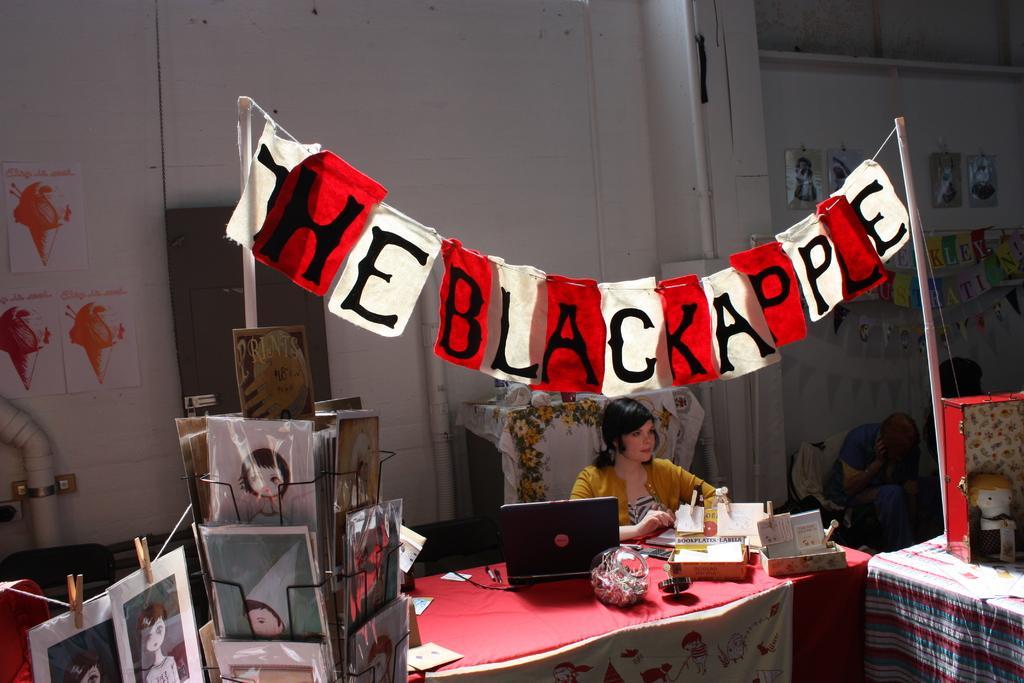In one or two sentences, can you explain what this image depicts? This person sitting. There is a table. On the table we can see laptop,box,papers. There is a banner attached with two poles. On the background we can see wall,posters 